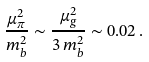Convert formula to latex. <formula><loc_0><loc_0><loc_500><loc_500>\frac { \mu _ { \pi } ^ { 2 } } { m _ { b } ^ { 2 } } \sim \frac { \mu _ { g } ^ { 2 } } { 3 \, m _ { b } ^ { 2 } } \sim 0 . 0 2 \, .</formula> 